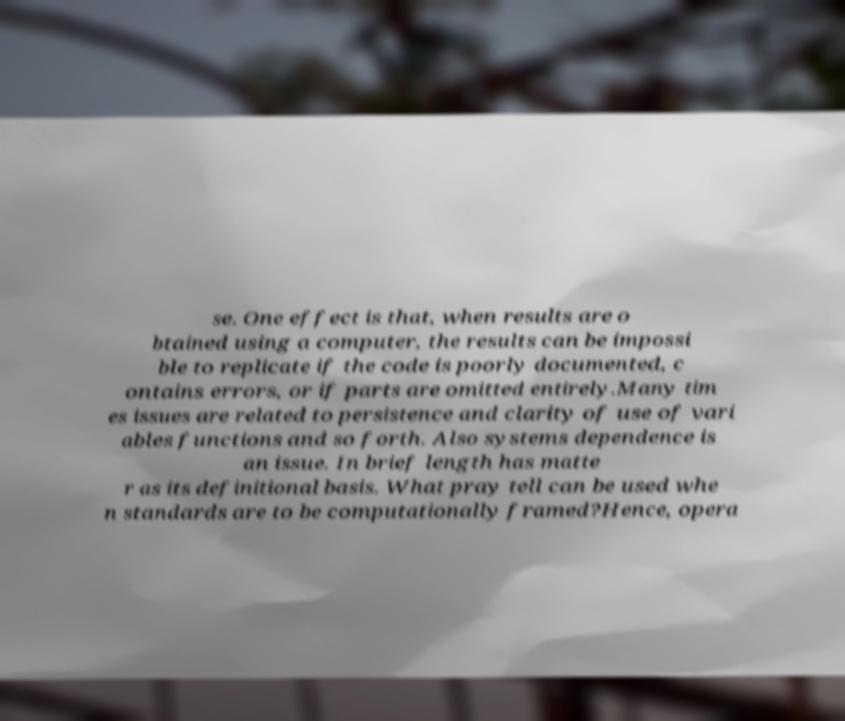Please read and relay the text visible in this image. What does it say? se. One effect is that, when results are o btained using a computer, the results can be impossi ble to replicate if the code is poorly documented, c ontains errors, or if parts are omitted entirely.Many tim es issues are related to persistence and clarity of use of vari ables functions and so forth. Also systems dependence is an issue. In brief length has matte r as its definitional basis. What pray tell can be used whe n standards are to be computationally framed?Hence, opera 